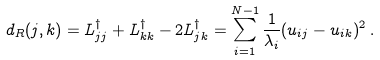<formula> <loc_0><loc_0><loc_500><loc_500>d _ { R } ( j , k ) = L ^ { \dagger } _ { j j } + L ^ { \dagger } _ { k k } - 2 L ^ { \dagger } _ { j k } = \sum _ { i = 1 } ^ { N - 1 } \frac { 1 } { \lambda _ { i } } ( u _ { i j } - u _ { i k } ) ^ { 2 } \, .</formula> 